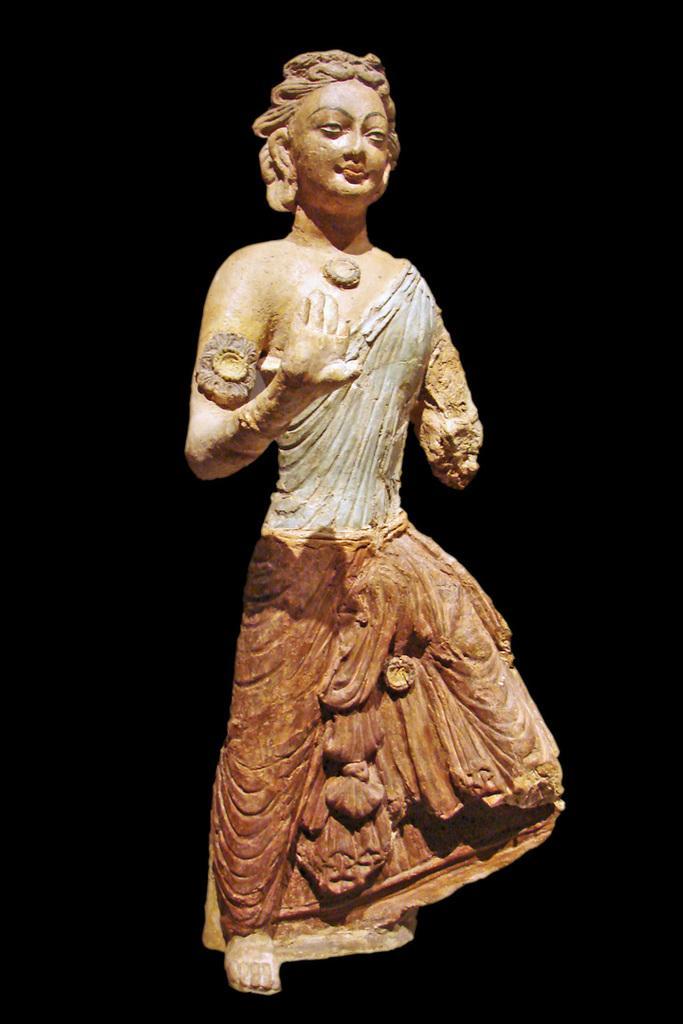Please provide a concise description of this image. In the image there is a sculpture and the background of the sculpture is dark. 